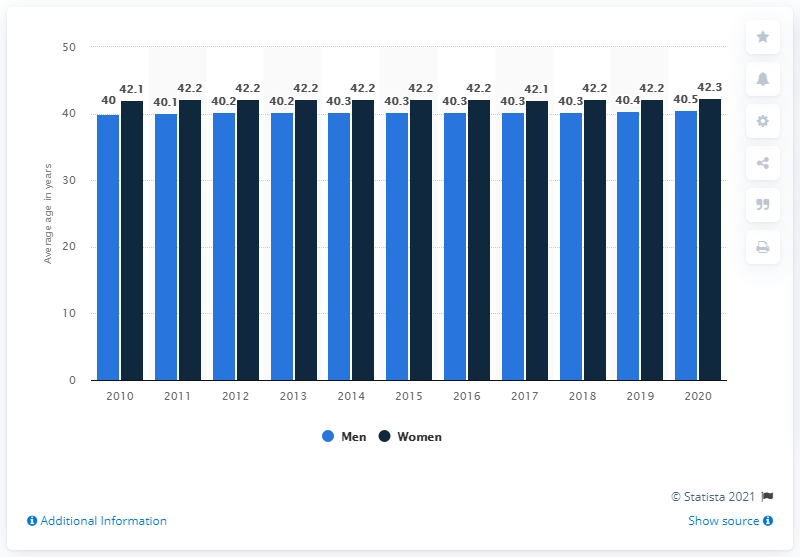List a handful of essential elements in this visual. The mode of men is 40.3%. It is indicated by blue. 